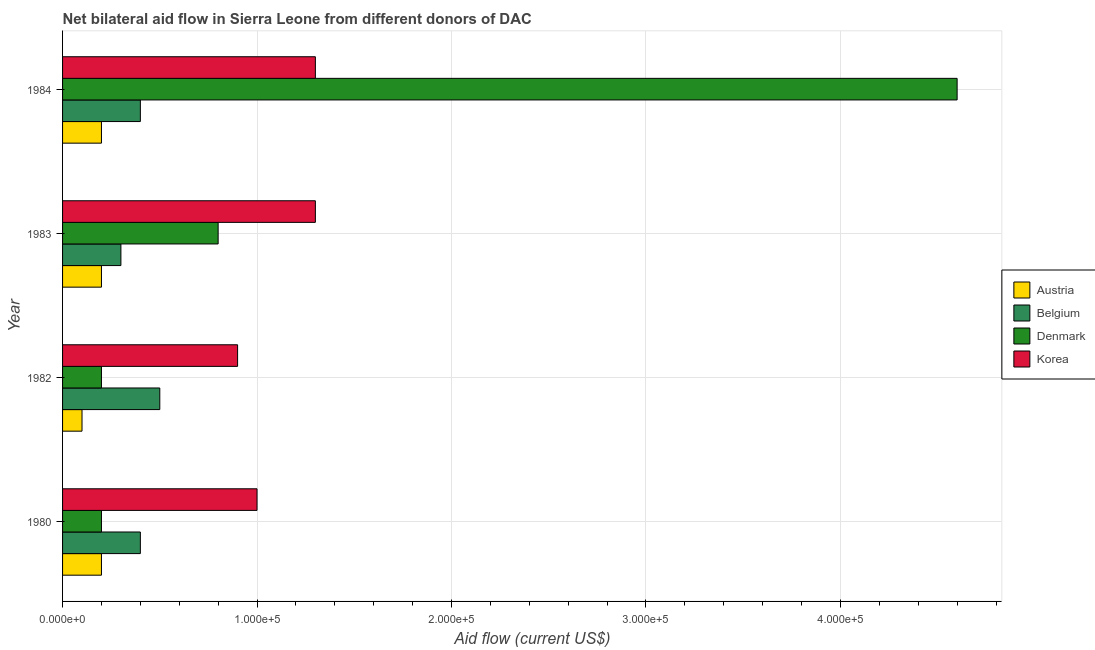How many different coloured bars are there?
Keep it short and to the point. 4. How many groups of bars are there?
Offer a terse response. 4. Are the number of bars per tick equal to the number of legend labels?
Offer a very short reply. Yes. How many bars are there on the 1st tick from the top?
Your answer should be very brief. 4. How many bars are there on the 4th tick from the bottom?
Make the answer very short. 4. What is the amount of aid given by belgium in 1984?
Give a very brief answer. 4.00e+04. Across all years, what is the maximum amount of aid given by belgium?
Your response must be concise. 5.00e+04. Across all years, what is the minimum amount of aid given by belgium?
Your answer should be very brief. 3.00e+04. In which year was the amount of aid given by denmark minimum?
Provide a succinct answer. 1980. What is the total amount of aid given by belgium in the graph?
Ensure brevity in your answer.  1.60e+05. What is the difference between the amount of aid given by denmark in 1980 and that in 1983?
Offer a terse response. -6.00e+04. What is the difference between the amount of aid given by denmark in 1982 and the amount of aid given by belgium in 1984?
Your answer should be compact. -2.00e+04. What is the average amount of aid given by korea per year?
Provide a succinct answer. 1.12e+05. In the year 1983, what is the difference between the amount of aid given by korea and amount of aid given by belgium?
Offer a very short reply. 1.00e+05. What is the ratio of the amount of aid given by korea in 1982 to that in 1983?
Your answer should be compact. 0.69. Is the amount of aid given by belgium in 1980 less than that in 1984?
Offer a very short reply. No. What is the difference between the highest and the second highest amount of aid given by denmark?
Your answer should be very brief. 3.80e+05. What is the difference between the highest and the lowest amount of aid given by denmark?
Ensure brevity in your answer.  4.40e+05. Is the sum of the amount of aid given by belgium in 1982 and 1983 greater than the maximum amount of aid given by korea across all years?
Your response must be concise. No. Is it the case that in every year, the sum of the amount of aid given by austria and amount of aid given by belgium is greater than the sum of amount of aid given by korea and amount of aid given by denmark?
Offer a terse response. No. What does the 2nd bar from the bottom in 1984 represents?
Ensure brevity in your answer.  Belgium. Is it the case that in every year, the sum of the amount of aid given by austria and amount of aid given by belgium is greater than the amount of aid given by denmark?
Offer a very short reply. No. What is the difference between two consecutive major ticks on the X-axis?
Make the answer very short. 1.00e+05. Are the values on the major ticks of X-axis written in scientific E-notation?
Offer a terse response. Yes. Does the graph contain grids?
Your answer should be very brief. Yes. Where does the legend appear in the graph?
Ensure brevity in your answer.  Center right. How many legend labels are there?
Your response must be concise. 4. How are the legend labels stacked?
Offer a very short reply. Vertical. What is the title of the graph?
Give a very brief answer. Net bilateral aid flow in Sierra Leone from different donors of DAC. Does "Luxembourg" appear as one of the legend labels in the graph?
Your answer should be very brief. No. What is the label or title of the X-axis?
Make the answer very short. Aid flow (current US$). What is the Aid flow (current US$) in Austria in 1982?
Offer a very short reply. 10000. What is the Aid flow (current US$) of Denmark in 1982?
Give a very brief answer. 2.00e+04. What is the Aid flow (current US$) of Austria in 1983?
Your response must be concise. 2.00e+04. What is the Aid flow (current US$) in Belgium in 1983?
Make the answer very short. 3.00e+04. What is the Aid flow (current US$) in Denmark in 1983?
Offer a terse response. 8.00e+04. What is the Aid flow (current US$) in Korea in 1984?
Your response must be concise. 1.30e+05. Across all years, what is the maximum Aid flow (current US$) in Austria?
Your answer should be very brief. 2.00e+04. Across all years, what is the maximum Aid flow (current US$) in Denmark?
Give a very brief answer. 4.60e+05. Across all years, what is the minimum Aid flow (current US$) in Belgium?
Make the answer very short. 3.00e+04. Across all years, what is the minimum Aid flow (current US$) of Denmark?
Provide a succinct answer. 2.00e+04. What is the total Aid flow (current US$) of Austria in the graph?
Offer a very short reply. 7.00e+04. What is the total Aid flow (current US$) of Denmark in the graph?
Provide a succinct answer. 5.80e+05. What is the total Aid flow (current US$) of Korea in the graph?
Make the answer very short. 4.50e+05. What is the difference between the Aid flow (current US$) of Austria in 1980 and that in 1982?
Your response must be concise. 10000. What is the difference between the Aid flow (current US$) of Belgium in 1980 and that in 1982?
Give a very brief answer. -10000. What is the difference between the Aid flow (current US$) of Denmark in 1980 and that in 1982?
Provide a short and direct response. 0. What is the difference between the Aid flow (current US$) of Denmark in 1980 and that in 1984?
Your answer should be compact. -4.40e+05. What is the difference between the Aid flow (current US$) of Korea in 1980 and that in 1984?
Your answer should be very brief. -3.00e+04. What is the difference between the Aid flow (current US$) of Austria in 1982 and that in 1983?
Provide a short and direct response. -10000. What is the difference between the Aid flow (current US$) in Belgium in 1982 and that in 1983?
Offer a terse response. 2.00e+04. What is the difference between the Aid flow (current US$) in Austria in 1982 and that in 1984?
Your response must be concise. -10000. What is the difference between the Aid flow (current US$) in Belgium in 1982 and that in 1984?
Ensure brevity in your answer.  10000. What is the difference between the Aid flow (current US$) in Denmark in 1982 and that in 1984?
Ensure brevity in your answer.  -4.40e+05. What is the difference between the Aid flow (current US$) of Korea in 1982 and that in 1984?
Offer a terse response. -4.00e+04. What is the difference between the Aid flow (current US$) of Austria in 1983 and that in 1984?
Make the answer very short. 0. What is the difference between the Aid flow (current US$) in Denmark in 1983 and that in 1984?
Offer a very short reply. -3.80e+05. What is the difference between the Aid flow (current US$) in Korea in 1983 and that in 1984?
Make the answer very short. 0. What is the difference between the Aid flow (current US$) of Austria in 1980 and the Aid flow (current US$) of Belgium in 1982?
Your answer should be compact. -3.00e+04. What is the difference between the Aid flow (current US$) in Belgium in 1980 and the Aid flow (current US$) in Korea in 1982?
Offer a terse response. -5.00e+04. What is the difference between the Aid flow (current US$) of Austria in 1980 and the Aid flow (current US$) of Denmark in 1983?
Make the answer very short. -6.00e+04. What is the difference between the Aid flow (current US$) in Austria in 1980 and the Aid flow (current US$) in Belgium in 1984?
Your answer should be very brief. -2.00e+04. What is the difference between the Aid flow (current US$) in Austria in 1980 and the Aid flow (current US$) in Denmark in 1984?
Your response must be concise. -4.40e+05. What is the difference between the Aid flow (current US$) of Belgium in 1980 and the Aid flow (current US$) of Denmark in 1984?
Your answer should be very brief. -4.20e+05. What is the difference between the Aid flow (current US$) of Belgium in 1980 and the Aid flow (current US$) of Korea in 1984?
Give a very brief answer. -9.00e+04. What is the difference between the Aid flow (current US$) of Denmark in 1980 and the Aid flow (current US$) of Korea in 1984?
Give a very brief answer. -1.10e+05. What is the difference between the Aid flow (current US$) of Austria in 1982 and the Aid flow (current US$) of Korea in 1983?
Your response must be concise. -1.20e+05. What is the difference between the Aid flow (current US$) of Belgium in 1982 and the Aid flow (current US$) of Denmark in 1983?
Keep it short and to the point. -3.00e+04. What is the difference between the Aid flow (current US$) in Belgium in 1982 and the Aid flow (current US$) in Korea in 1983?
Offer a very short reply. -8.00e+04. What is the difference between the Aid flow (current US$) in Austria in 1982 and the Aid flow (current US$) in Denmark in 1984?
Make the answer very short. -4.50e+05. What is the difference between the Aid flow (current US$) of Austria in 1982 and the Aid flow (current US$) of Korea in 1984?
Offer a very short reply. -1.20e+05. What is the difference between the Aid flow (current US$) in Belgium in 1982 and the Aid flow (current US$) in Denmark in 1984?
Your answer should be very brief. -4.10e+05. What is the difference between the Aid flow (current US$) of Denmark in 1982 and the Aid flow (current US$) of Korea in 1984?
Keep it short and to the point. -1.10e+05. What is the difference between the Aid flow (current US$) of Austria in 1983 and the Aid flow (current US$) of Belgium in 1984?
Your response must be concise. -2.00e+04. What is the difference between the Aid flow (current US$) of Austria in 1983 and the Aid flow (current US$) of Denmark in 1984?
Provide a short and direct response. -4.40e+05. What is the difference between the Aid flow (current US$) of Belgium in 1983 and the Aid flow (current US$) of Denmark in 1984?
Offer a very short reply. -4.30e+05. What is the difference between the Aid flow (current US$) of Denmark in 1983 and the Aid flow (current US$) of Korea in 1984?
Offer a terse response. -5.00e+04. What is the average Aid flow (current US$) of Austria per year?
Your response must be concise. 1.75e+04. What is the average Aid flow (current US$) in Denmark per year?
Offer a terse response. 1.45e+05. What is the average Aid flow (current US$) of Korea per year?
Provide a short and direct response. 1.12e+05. In the year 1980, what is the difference between the Aid flow (current US$) of Austria and Aid flow (current US$) of Korea?
Your response must be concise. -8.00e+04. In the year 1980, what is the difference between the Aid flow (current US$) in Belgium and Aid flow (current US$) in Korea?
Ensure brevity in your answer.  -6.00e+04. In the year 1980, what is the difference between the Aid flow (current US$) in Denmark and Aid flow (current US$) in Korea?
Your answer should be very brief. -8.00e+04. In the year 1982, what is the difference between the Aid flow (current US$) of Austria and Aid flow (current US$) of Belgium?
Keep it short and to the point. -4.00e+04. In the year 1982, what is the difference between the Aid flow (current US$) in Austria and Aid flow (current US$) in Korea?
Give a very brief answer. -8.00e+04. In the year 1982, what is the difference between the Aid flow (current US$) of Belgium and Aid flow (current US$) of Denmark?
Offer a very short reply. 3.00e+04. In the year 1982, what is the difference between the Aid flow (current US$) in Belgium and Aid flow (current US$) in Korea?
Your answer should be compact. -4.00e+04. In the year 1983, what is the difference between the Aid flow (current US$) of Austria and Aid flow (current US$) of Belgium?
Keep it short and to the point. -10000. In the year 1983, what is the difference between the Aid flow (current US$) of Austria and Aid flow (current US$) of Korea?
Give a very brief answer. -1.10e+05. In the year 1983, what is the difference between the Aid flow (current US$) in Belgium and Aid flow (current US$) in Denmark?
Your answer should be compact. -5.00e+04. In the year 1984, what is the difference between the Aid flow (current US$) of Austria and Aid flow (current US$) of Denmark?
Provide a short and direct response. -4.40e+05. In the year 1984, what is the difference between the Aid flow (current US$) of Belgium and Aid flow (current US$) of Denmark?
Ensure brevity in your answer.  -4.20e+05. In the year 1984, what is the difference between the Aid flow (current US$) in Belgium and Aid flow (current US$) in Korea?
Ensure brevity in your answer.  -9.00e+04. What is the ratio of the Aid flow (current US$) in Austria in 1980 to that in 1982?
Make the answer very short. 2. What is the ratio of the Aid flow (current US$) in Denmark in 1980 to that in 1982?
Provide a succinct answer. 1. What is the ratio of the Aid flow (current US$) in Belgium in 1980 to that in 1983?
Give a very brief answer. 1.33. What is the ratio of the Aid flow (current US$) in Korea in 1980 to that in 1983?
Your response must be concise. 0.77. What is the ratio of the Aid flow (current US$) in Austria in 1980 to that in 1984?
Your response must be concise. 1. What is the ratio of the Aid flow (current US$) in Belgium in 1980 to that in 1984?
Provide a succinct answer. 1. What is the ratio of the Aid flow (current US$) of Denmark in 1980 to that in 1984?
Give a very brief answer. 0.04. What is the ratio of the Aid flow (current US$) in Korea in 1980 to that in 1984?
Make the answer very short. 0.77. What is the ratio of the Aid flow (current US$) of Belgium in 1982 to that in 1983?
Offer a terse response. 1.67. What is the ratio of the Aid flow (current US$) of Denmark in 1982 to that in 1983?
Your answer should be very brief. 0.25. What is the ratio of the Aid flow (current US$) of Korea in 1982 to that in 1983?
Keep it short and to the point. 0.69. What is the ratio of the Aid flow (current US$) in Denmark in 1982 to that in 1984?
Make the answer very short. 0.04. What is the ratio of the Aid flow (current US$) in Korea in 1982 to that in 1984?
Offer a very short reply. 0.69. What is the ratio of the Aid flow (current US$) in Austria in 1983 to that in 1984?
Offer a terse response. 1. What is the ratio of the Aid flow (current US$) of Denmark in 1983 to that in 1984?
Offer a very short reply. 0.17. What is the difference between the highest and the second highest Aid flow (current US$) in Austria?
Provide a succinct answer. 0. What is the difference between the highest and the lowest Aid flow (current US$) of Austria?
Make the answer very short. 10000. What is the difference between the highest and the lowest Aid flow (current US$) in Denmark?
Your response must be concise. 4.40e+05. What is the difference between the highest and the lowest Aid flow (current US$) in Korea?
Your answer should be very brief. 4.00e+04. 